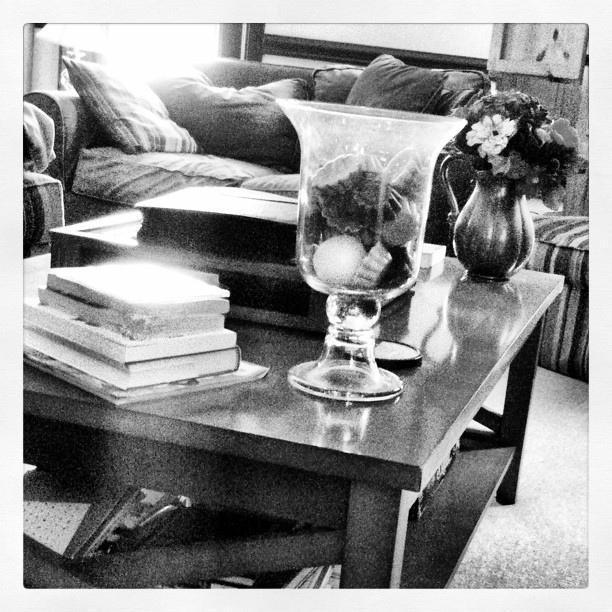How many books are there?
Give a very brief answer. 7. How many vases are in the photo?
Give a very brief answer. 2. 